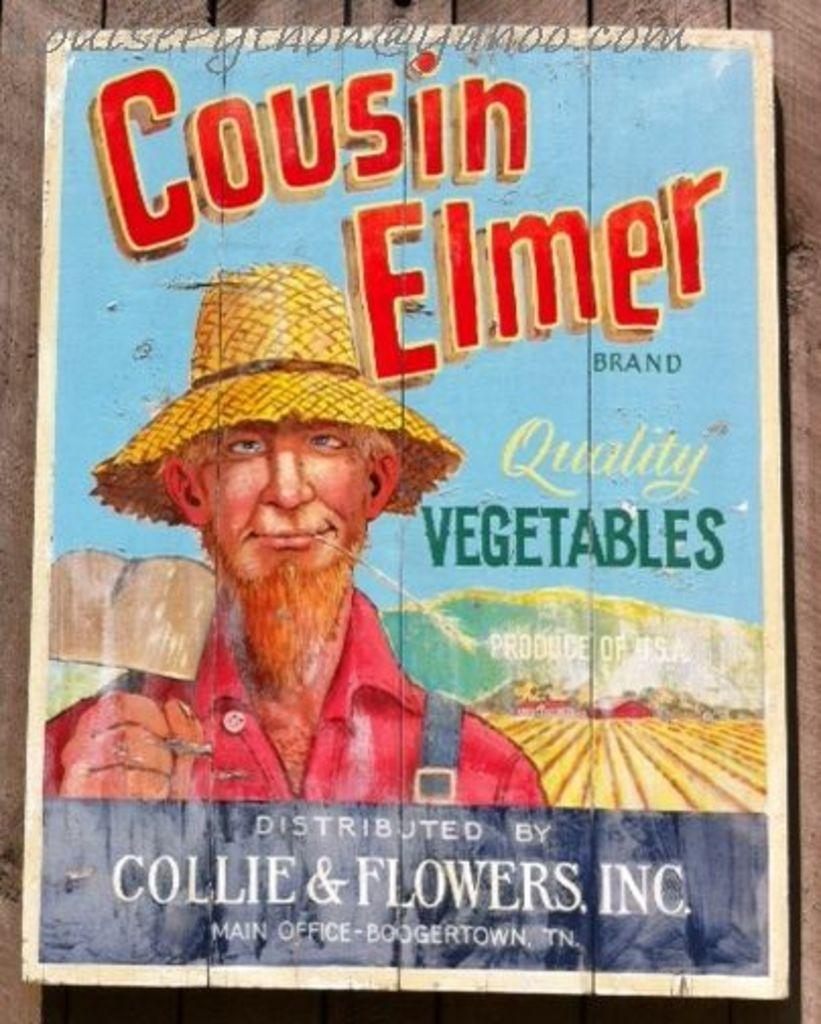What is on the wall in the image? There is a poster on the wall in the image. What can be seen on the poster? The poster contains an image. What else is present on the poster besides the image? The poster contains text. How many dresses are hanging on the wall in the image? There are no dresses present in the image; it only features a poster on the wall. What is the amount of attraction in the image? There is no attraction mentioned or depicted in the image; it only features a poster on the wall. 